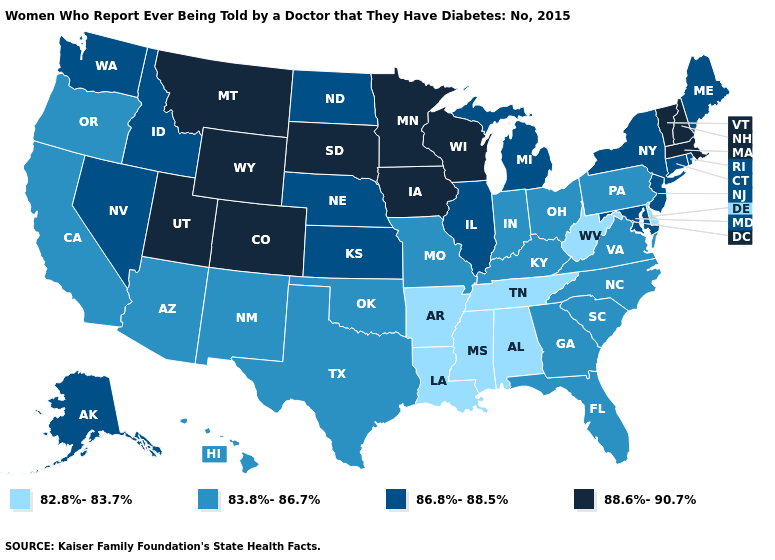Name the states that have a value in the range 88.6%-90.7%?
Write a very short answer. Colorado, Iowa, Massachusetts, Minnesota, Montana, New Hampshire, South Dakota, Utah, Vermont, Wisconsin, Wyoming. Which states hav the highest value in the Northeast?
Be succinct. Massachusetts, New Hampshire, Vermont. Does Nevada have a lower value than Massachusetts?
Quick response, please. Yes. Does Maryland have the highest value in the South?
Concise answer only. Yes. What is the lowest value in states that border Arizona?
Write a very short answer. 83.8%-86.7%. What is the value of Hawaii?
Concise answer only. 83.8%-86.7%. Name the states that have a value in the range 82.8%-83.7%?
Write a very short answer. Alabama, Arkansas, Delaware, Louisiana, Mississippi, Tennessee, West Virginia. What is the value of Hawaii?
Answer briefly. 83.8%-86.7%. Does the first symbol in the legend represent the smallest category?
Give a very brief answer. Yes. Does Utah have the lowest value in the West?
Be succinct. No. Does Oregon have the lowest value in the West?
Give a very brief answer. Yes. Name the states that have a value in the range 88.6%-90.7%?
Quick response, please. Colorado, Iowa, Massachusetts, Minnesota, Montana, New Hampshire, South Dakota, Utah, Vermont, Wisconsin, Wyoming. What is the lowest value in the USA?
Quick response, please. 82.8%-83.7%. Is the legend a continuous bar?
Keep it brief. No. What is the highest value in the USA?
Quick response, please. 88.6%-90.7%. 